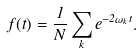Convert formula to latex. <formula><loc_0><loc_0><loc_500><loc_500>f ( t ) = \frac { 1 } { N } \sum _ { k } e ^ { - 2 \omega _ { k } t } .</formula> 